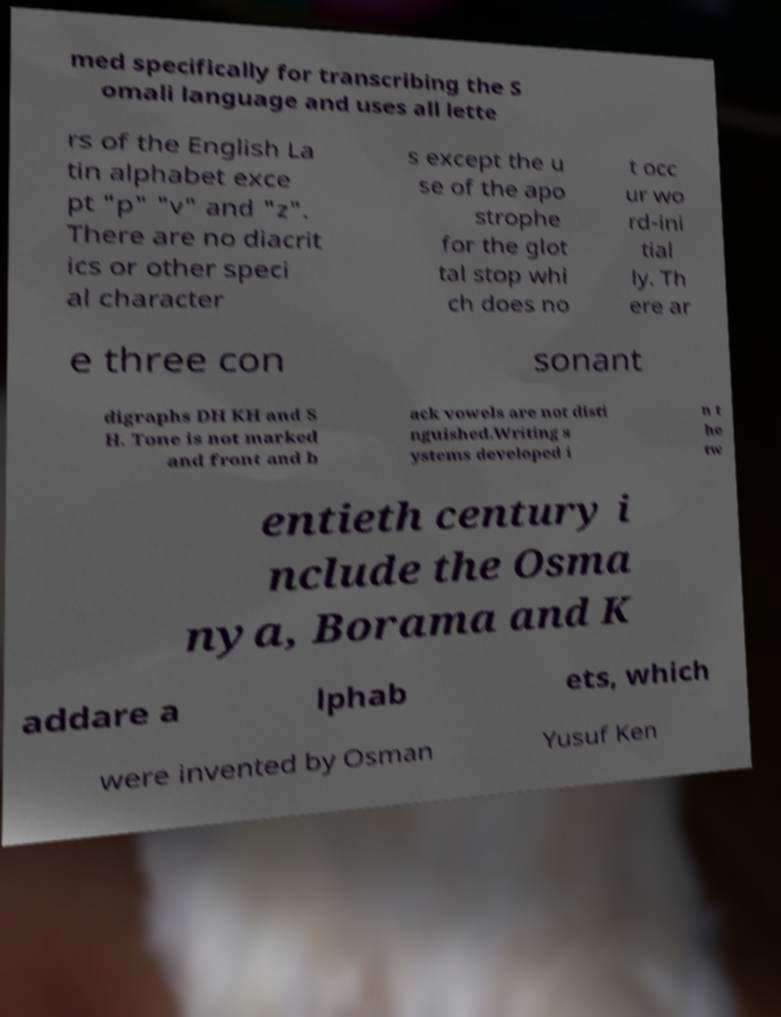What messages or text are displayed in this image? I need them in a readable, typed format. med specifically for transcribing the S omali language and uses all lette rs of the English La tin alphabet exce pt "p" "v" and "z". There are no diacrit ics or other speci al character s except the u se of the apo strophe for the glot tal stop whi ch does no t occ ur wo rd-ini tial ly. Th ere ar e three con sonant digraphs DH KH and S H. Tone is not marked and front and b ack vowels are not disti nguished.Writing s ystems developed i n t he tw entieth century i nclude the Osma nya, Borama and K addare a lphab ets, which were invented by Osman Yusuf Ken 